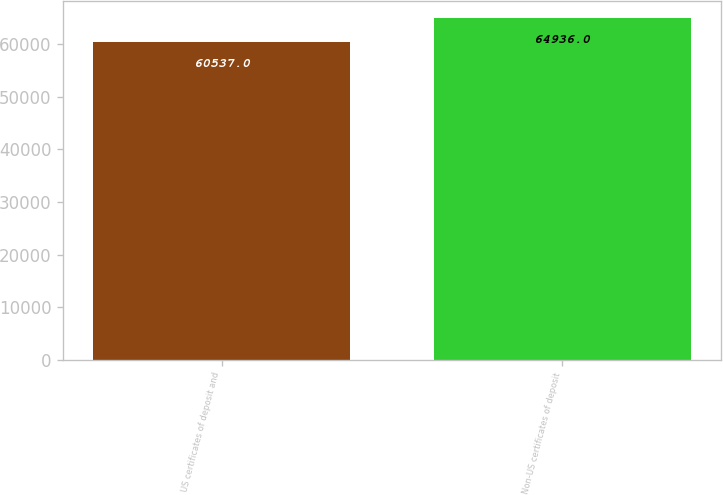<chart> <loc_0><loc_0><loc_500><loc_500><bar_chart><fcel>US certificates of deposit and<fcel>Non-US certificates of deposit<nl><fcel>60537<fcel>64936<nl></chart> 